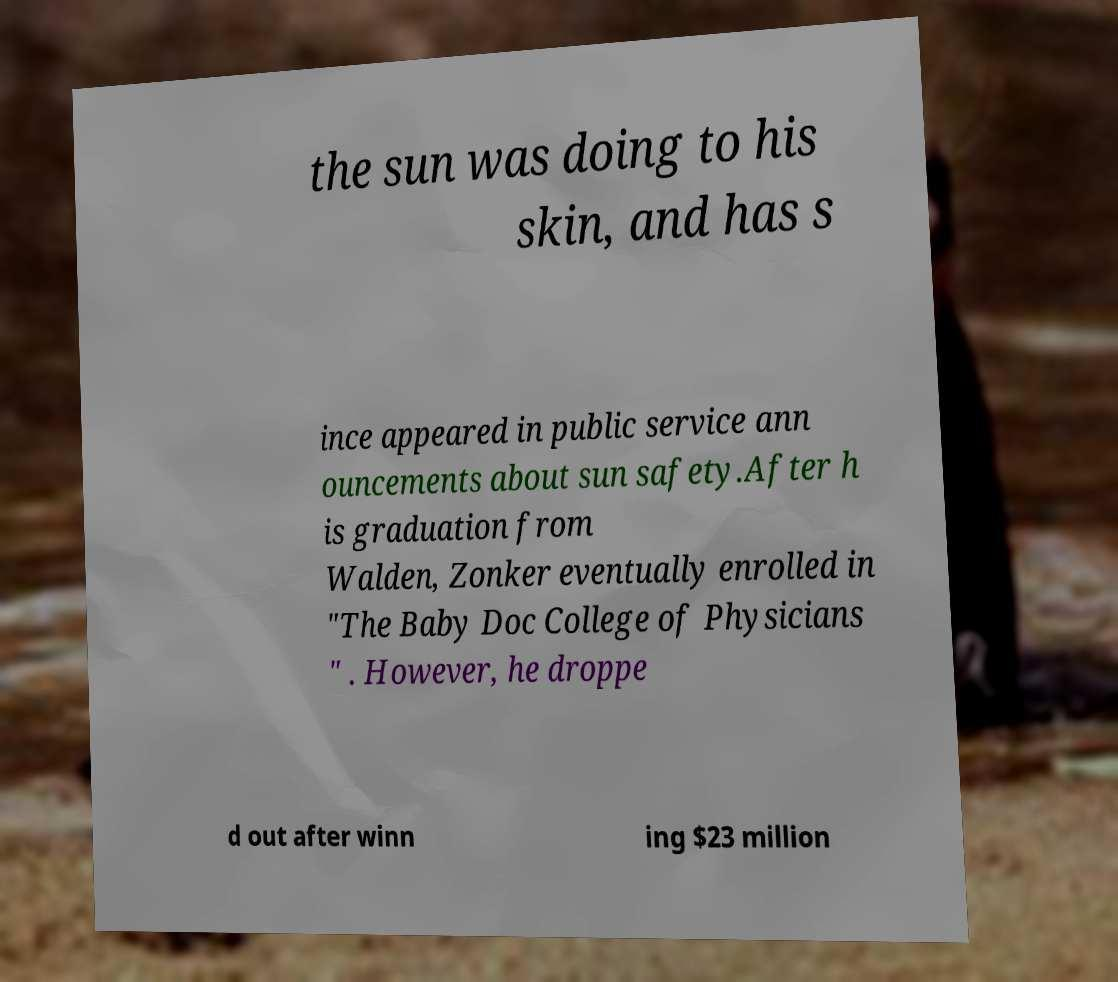For documentation purposes, I need the text within this image transcribed. Could you provide that? the sun was doing to his skin, and has s ince appeared in public service ann ouncements about sun safety.After h is graduation from Walden, Zonker eventually enrolled in "The Baby Doc College of Physicians " . However, he droppe d out after winn ing $23 million 